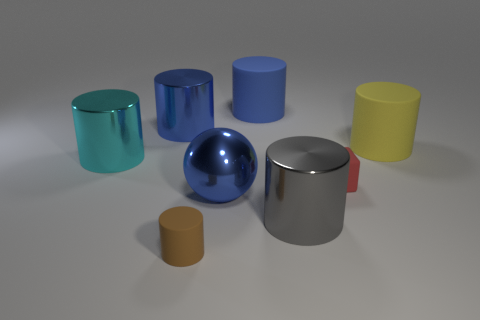Subtract all brown cylinders. How many cylinders are left? 5 Subtract all large cyan cylinders. How many cylinders are left? 5 Subtract all purple cylinders. Subtract all purple cubes. How many cylinders are left? 6 Add 1 spheres. How many objects exist? 9 Subtract all balls. How many objects are left? 7 Add 8 red rubber cubes. How many red rubber cubes are left? 9 Add 6 balls. How many balls exist? 7 Subtract 0 red spheres. How many objects are left? 8 Subtract all large red matte objects. Subtract all blue things. How many objects are left? 5 